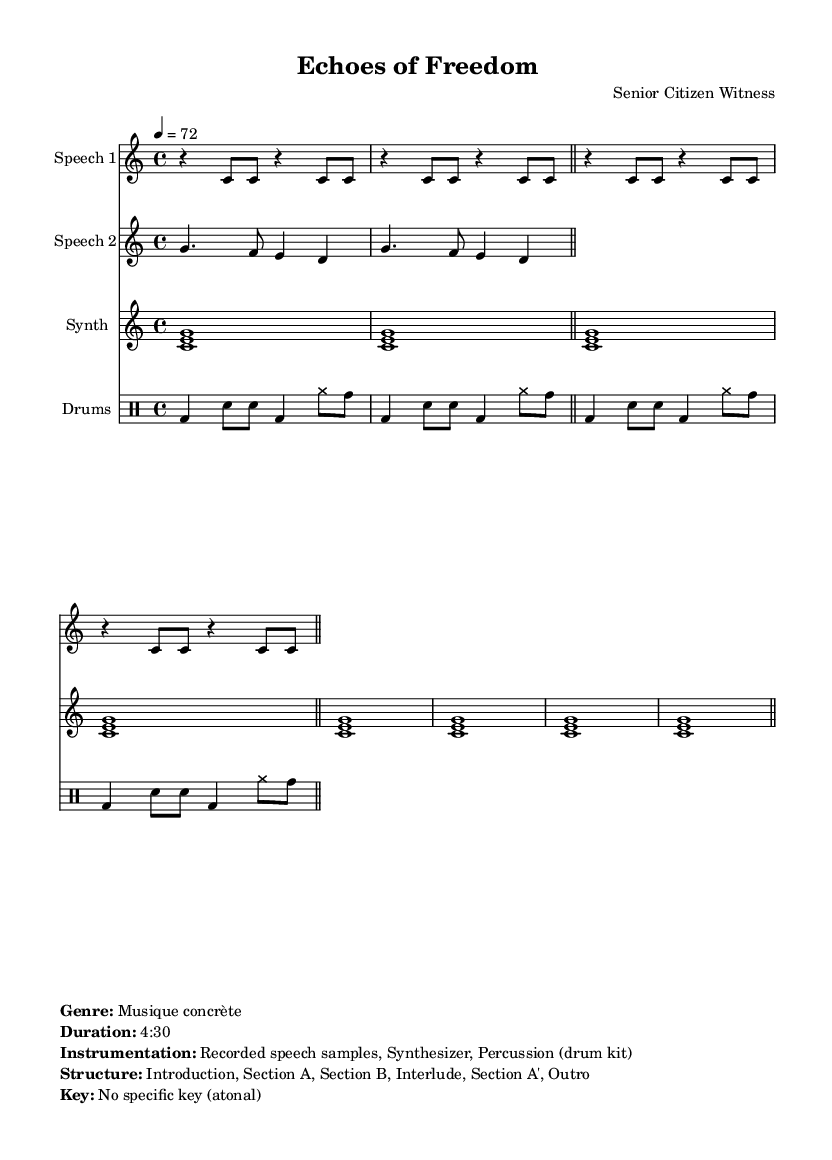What is the time signature of this music? The time signature is indicated at the beginning of the score as 4/4, which means there are four beats in each measure.
Answer: 4/4 What is the tempo marking of this piece? The tempo marking is shown as quarter note equals 72, indicating the speed at which the piece should be played.
Answer: 72 How many sections are in the structure of the piece? The structure outlined in the markup states there are five distinct sections: Introduction, Section A, Section B, Interlude, and Section A'.
Answer: 5 What instruments are used in this composition? The markup lists the instrumentation as "Recorded speech samples, Synthesizer, Percussion (drum kit)", detailing the elements used in the music.
Answer: Recorded speech samples, Synthesizer, Percussion (drum kit) Is there a specific key the piece is centered around? The markup notes that there is no specific key, indicating that the composition is atonal, which is common in experimental music.
Answer: No specific key What type of music does this sheet represent? The genre is explicitly labeled in the markup as "Musique concrète," which refers to a type of experimental music using recorded sounds.
Answer: Musique concrète 